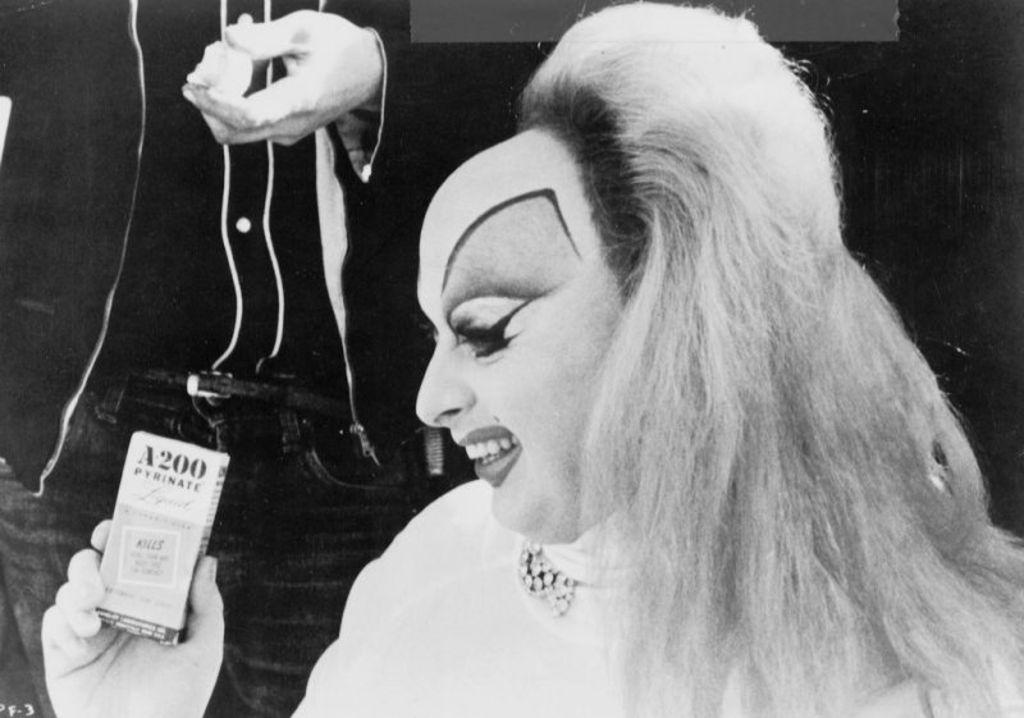Who is present in the image? There is a woman in the image. What is the woman wearing? The woman is wearing a white dress. What is the woman holding in the image? The woman is holding a tag. What is the tag attached to? The tag is attached to a pant. Whose hand is visible in the image? A person's hand is visible in the image. How long does it take for the woman to smash the minute in the image? There is no mention of smashing or minutes in the image, so this question cannot be answered. 